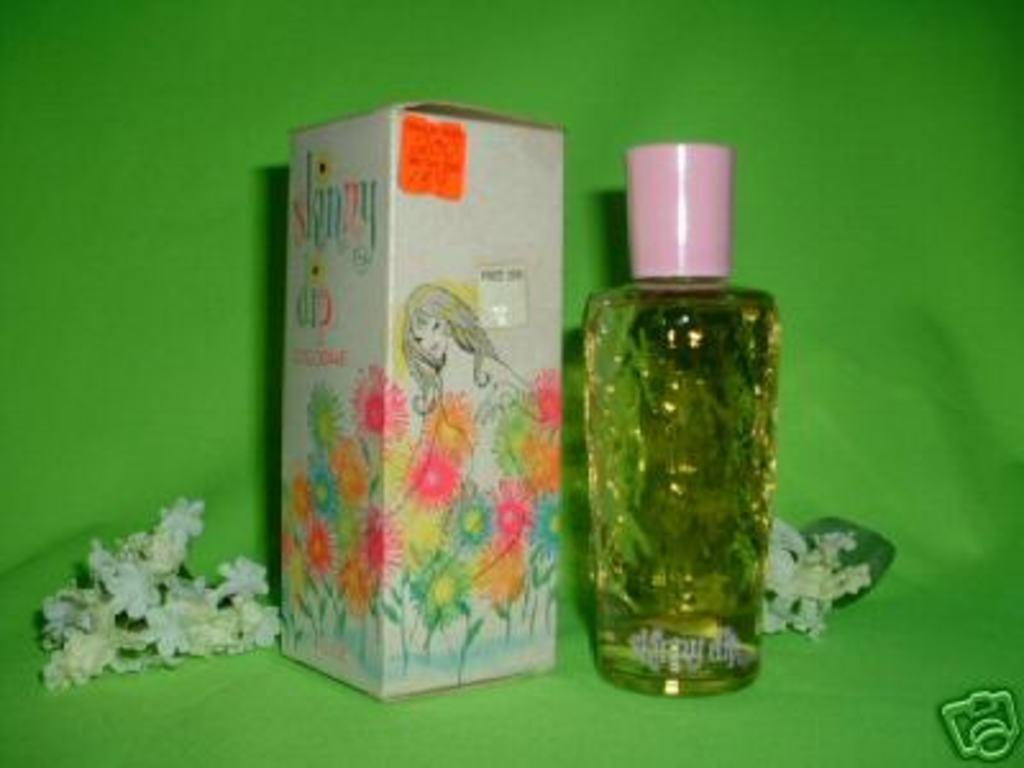<image>
Present a compact description of the photo's key features. Bottle of perfume next to a box with the word "skinny" on it. 